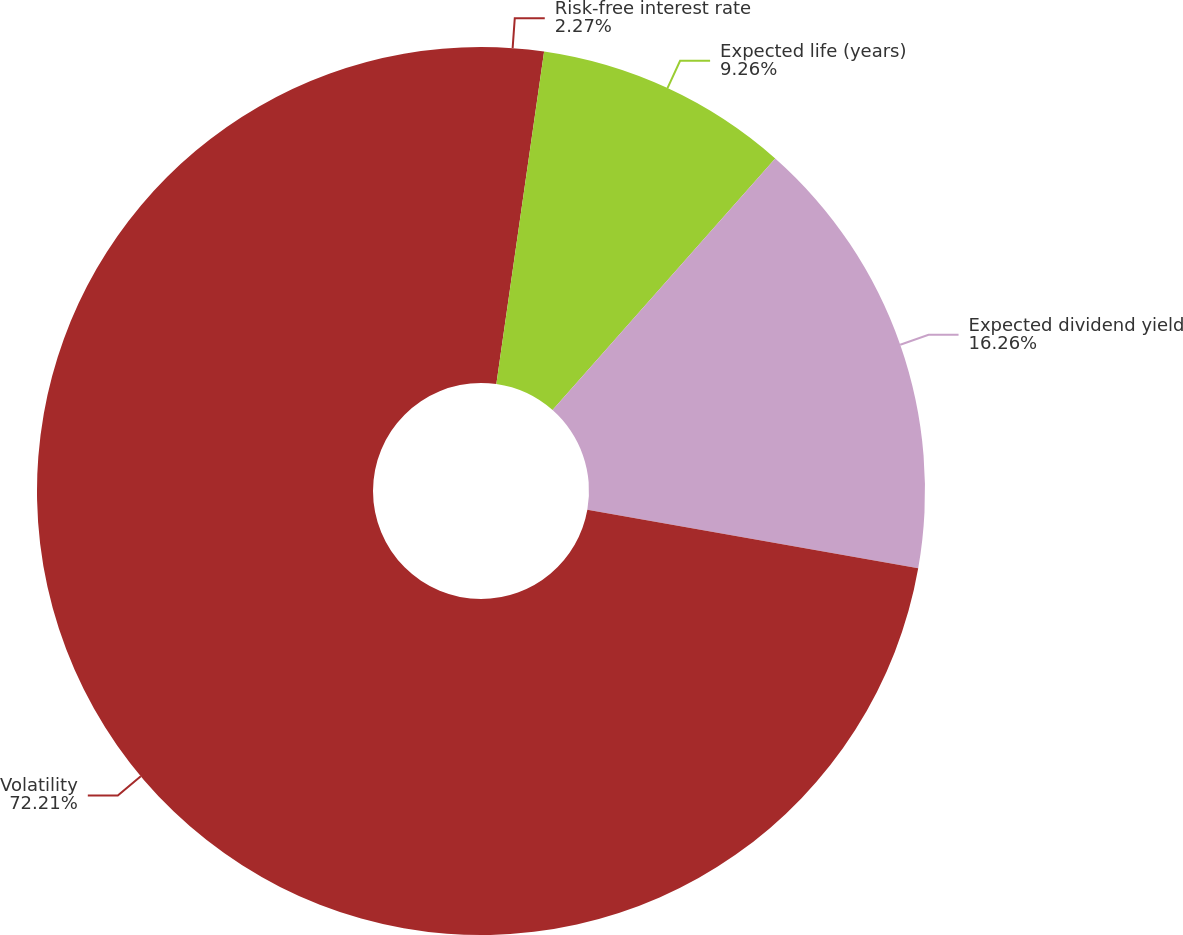Convert chart to OTSL. <chart><loc_0><loc_0><loc_500><loc_500><pie_chart><fcel>Risk-free interest rate<fcel>Expected life (years)<fcel>Expected dividend yield<fcel>Volatility<nl><fcel>2.27%<fcel>9.26%<fcel>16.26%<fcel>72.22%<nl></chart> 